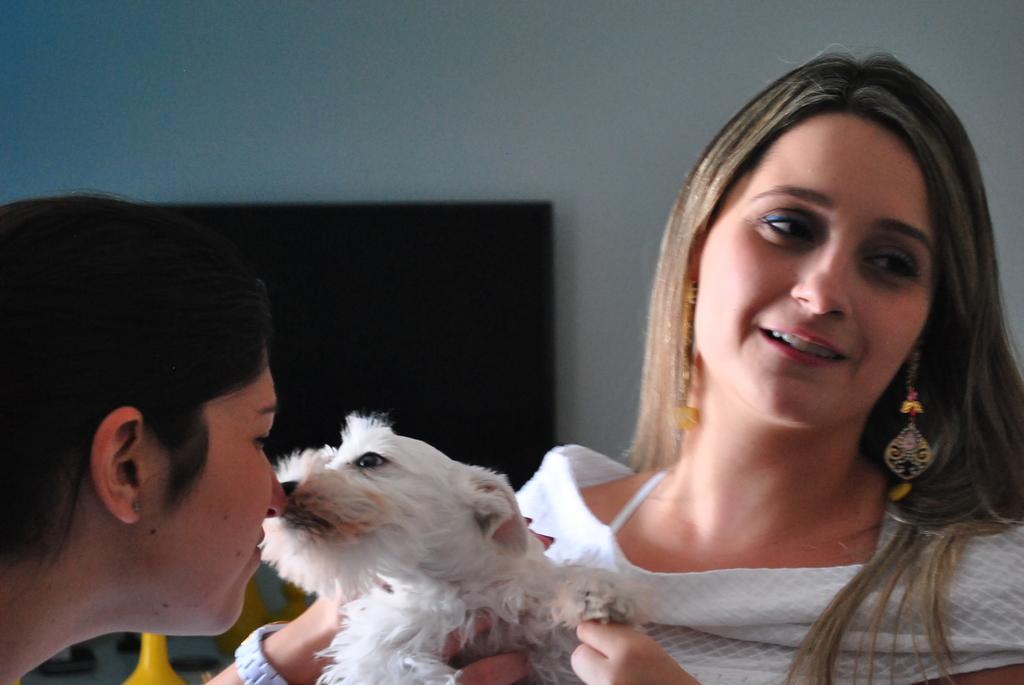How would you summarize this image in a sentence or two? In this image I can see two women and a dog. I can see she is wearing a white top. 